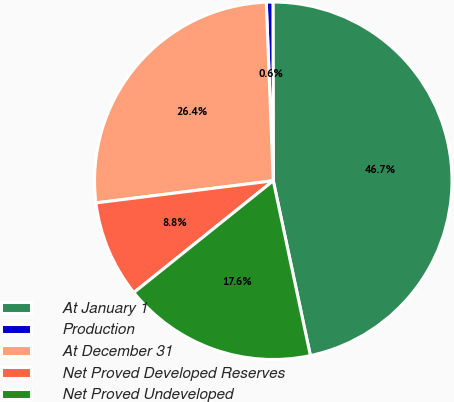Convert chart to OTSL. <chart><loc_0><loc_0><loc_500><loc_500><pie_chart><fcel>At January 1<fcel>Production<fcel>At December 31<fcel>Net Proved Developed Reserves<fcel>Net Proved Undeveloped<nl><fcel>46.69%<fcel>0.6%<fcel>26.35%<fcel>8.78%<fcel>17.57%<nl></chart> 